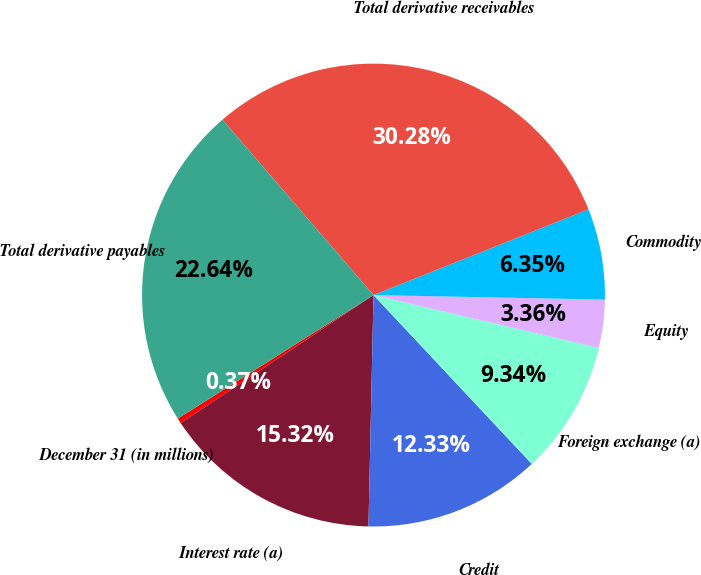Convert chart to OTSL. <chart><loc_0><loc_0><loc_500><loc_500><pie_chart><fcel>December 31 (in millions)<fcel>Interest rate (a)<fcel>Credit<fcel>Foreign exchange (a)<fcel>Equity<fcel>Commodity<fcel>Total derivative receivables<fcel>Total derivative payables<nl><fcel>0.37%<fcel>15.32%<fcel>12.33%<fcel>9.34%<fcel>3.36%<fcel>6.35%<fcel>30.27%<fcel>22.64%<nl></chart> 